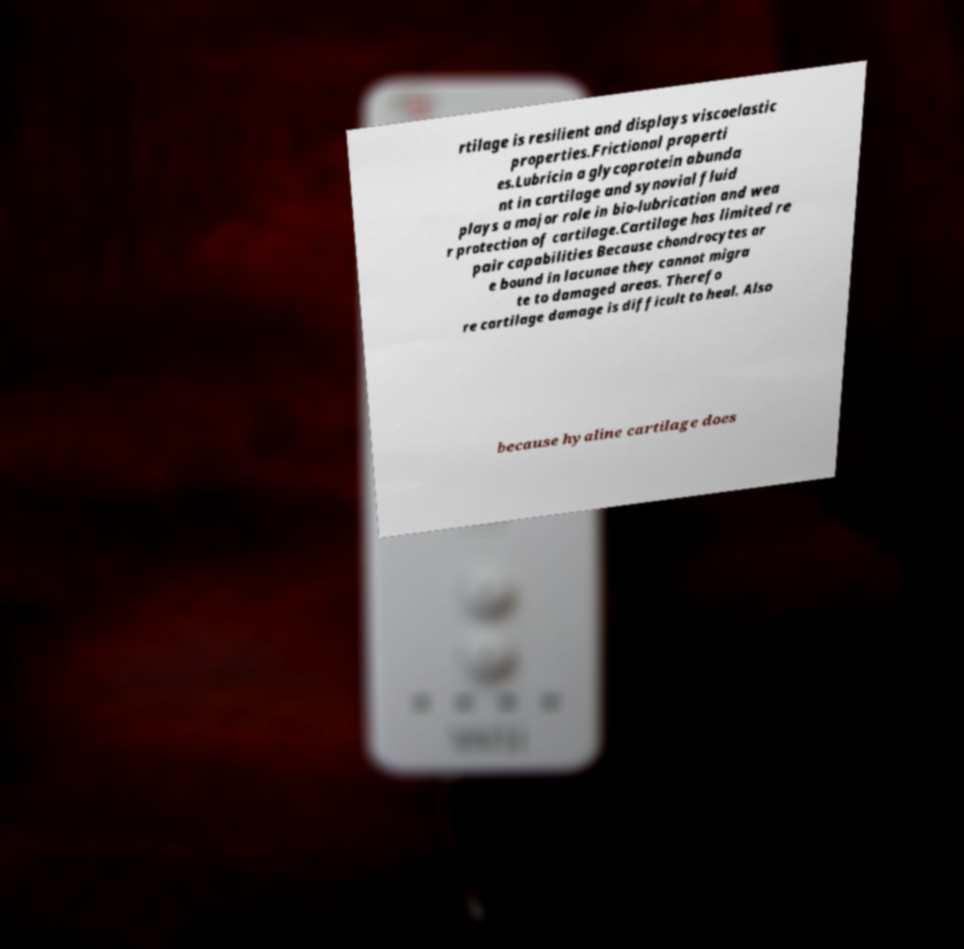Could you assist in decoding the text presented in this image and type it out clearly? rtilage is resilient and displays viscoelastic properties.Frictional properti es.Lubricin a glycoprotein abunda nt in cartilage and synovial fluid plays a major role in bio-lubrication and wea r protection of cartilage.Cartilage has limited re pair capabilities Because chondrocytes ar e bound in lacunae they cannot migra te to damaged areas. Therefo re cartilage damage is difficult to heal. Also because hyaline cartilage does 